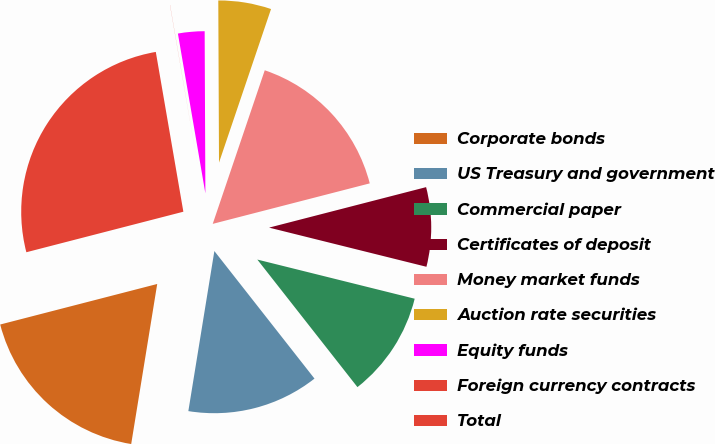<chart> <loc_0><loc_0><loc_500><loc_500><pie_chart><fcel>Corporate bonds<fcel>US Treasury and government<fcel>Commercial paper<fcel>Certificates of deposit<fcel>Money market funds<fcel>Auction rate securities<fcel>Equity funds<fcel>Foreign currency contracts<fcel>Total<nl><fcel>18.42%<fcel>13.16%<fcel>10.53%<fcel>7.9%<fcel>15.79%<fcel>5.27%<fcel>2.64%<fcel>0.01%<fcel>26.31%<nl></chart> 